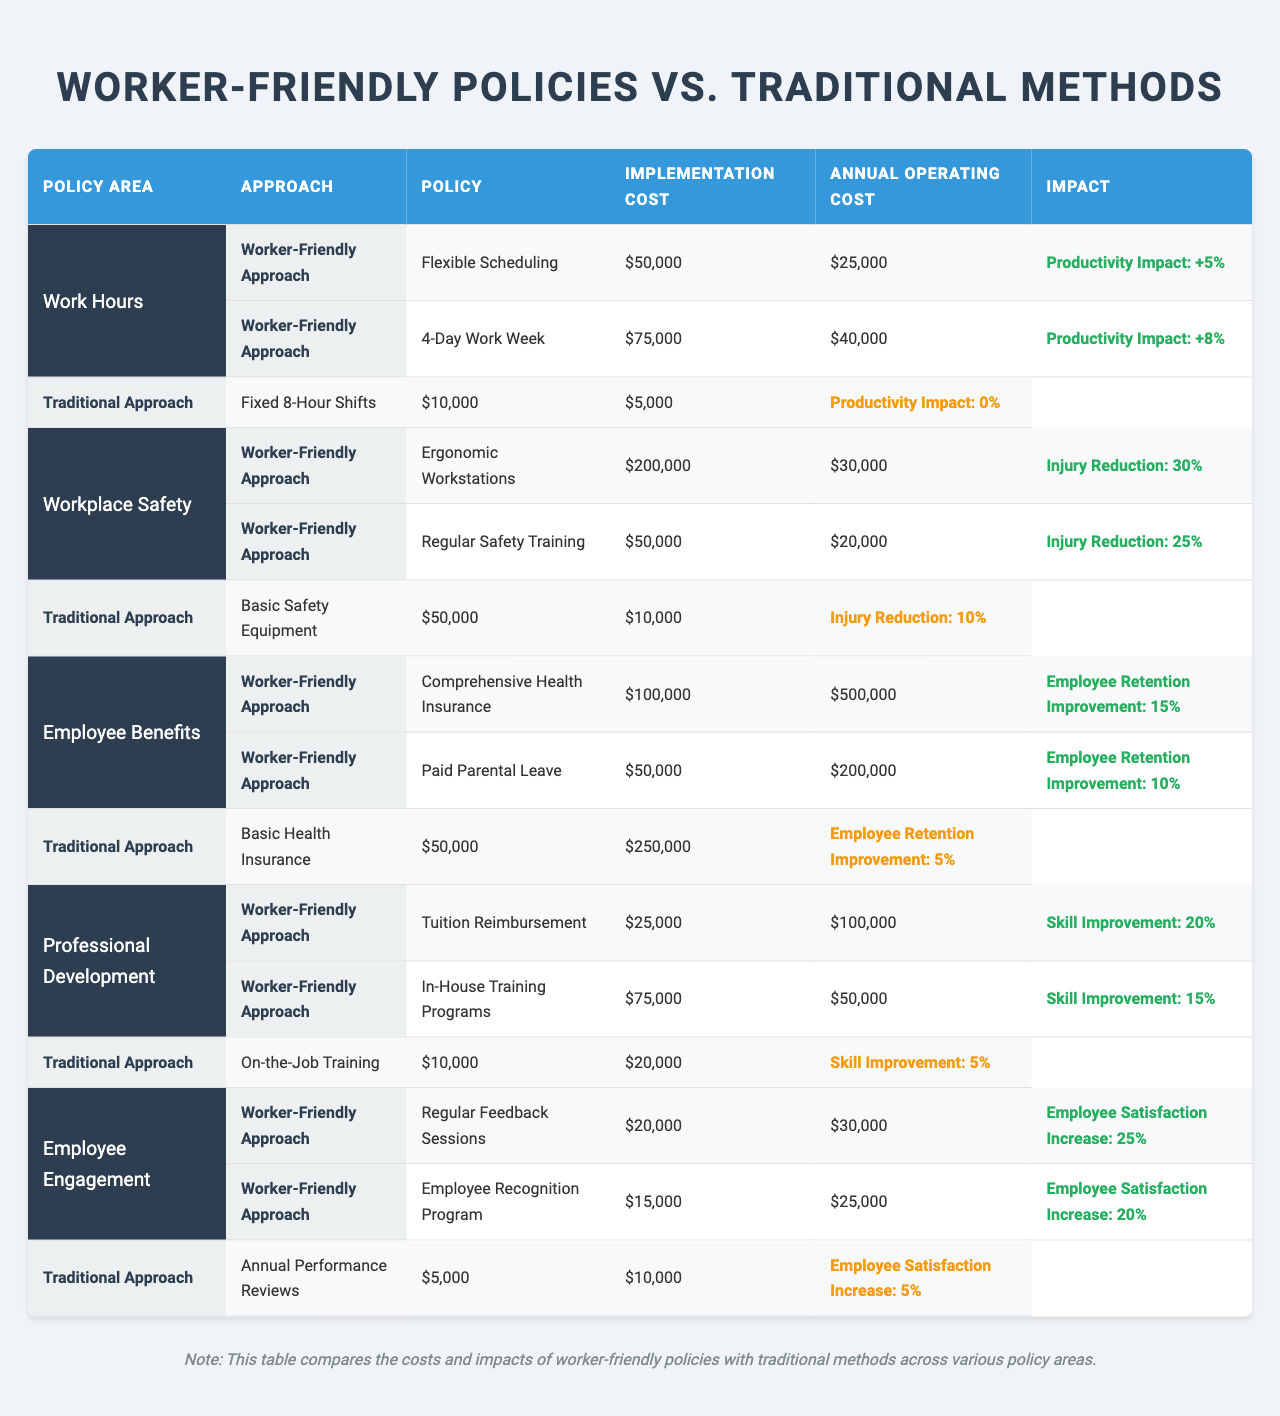What is the implementation cost of the Flexible Scheduling policy? The table shows that the implementation cost of the Flexible Scheduling policy under Worker-Friendly Approaches is listed as $50,000.
Answer: $50,000 Which approach has a higher annual operating cost: Comprehensive Health Insurance or Basic Health Insurance? In the table, the annual operating cost for Comprehensive Health Insurance is $500,000, while for Basic Health Insurance, it is $250,000. Since $500,000 is greater than $250,000, the Comprehensive Health Insurance has the higher operating cost.
Answer: Comprehensive Health Insurance What is the productivity impact of the 4-Day Work Week policy? According to the data, the productivity impact associated with the 4-Day Work Week is listed as +8%.
Answer: +8% Which policy area has the highest implementation cost in the Worker-Friendly Approach? Reviewing the implementation costs, Ergonomic Workstations in the Workplace Safety policy area has the highest implementation cost of $200,000 compared to other policies listed.
Answer: Workplace Safety (Ergonomic Workstations: $200,000) What is the total annual operating cost for Employee Benefits policies? To find the total annual operating cost for Employee Benefits, we add the costs of Comprehensive Health Insurance ($500,000) and Paid Parental Leave ($200,000): $500,000 + $200,000 = $700,000.
Answer: $700,000 Is there any policy in the Traditional Approach that has a productivity impact greater than 0%? The table indicates that all policies under the Traditional Approach have a productivity impact of 0% or less, therefore, there are no policies with a productivity impact greater than 0%.
Answer: No What is the average implementation cost of Worker-Friendly policies? The implementation costs for Worker-Friendly policies are as follows: Flexible Scheduling ($50,000), 4-Day Work Week ($75,000), Ergonomic Workstations ($200,000), Regular Safety Training ($50,000), Comprehensive Health Insurance ($100,000), Paid Parental Leave ($50,000), Tuition Reimbursement ($25,000), In-House Training Programs ($75,000), Regular Feedback Sessions ($20,000), and Employee Recognition Program ($15,000). The sum is $50,000 + $75,000 + $200,000 + $50,000 + $100,000 + $50,000 + $25,000 + $75,000 + $20,000 + $15,000 = $660,000, divided by the number of policies (10) gives an average of $66,000.
Answer: $66,000 Which Worker-Friendly policy shows the largest injury reduction? From the data, Ergonomic Workstations shows the largest injury reduction at 30%, compared to Regular Safety Training at 25%.
Answer: Ergonomic Workstations (30%) If a company opts for both Worker-Friendly policies in Workplace Safety, what would be the combined implementation cost? The implementation costs for Ergonomic Workstations is $200,000, and for Regular Safety Training is $50,000. Therefore, the combined implementation cost would be $200,000 + $50,000 = $250,000.
Answer: $250,000 Which policy is likely to improve employee retention the most based on the data? Among the Worker-Friendly policies listed, Comprehensive Health Insurance has the highest improvement in employee retention at 15%, compared to Paid Parental Leave (10%) and Basic Health Insurance (5%).
Answer: Comprehensive Health Insurance (15%) 